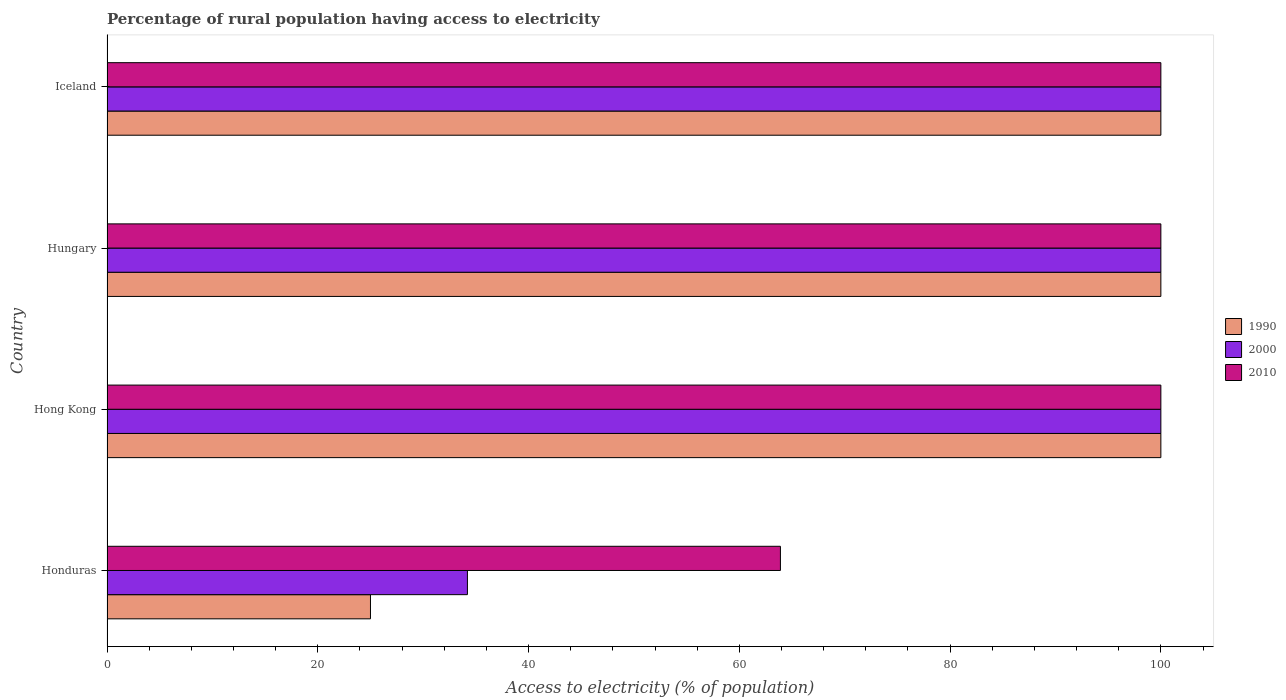How many different coloured bars are there?
Offer a terse response. 3. How many groups of bars are there?
Offer a very short reply. 4. Are the number of bars per tick equal to the number of legend labels?
Your answer should be very brief. Yes. Are the number of bars on each tick of the Y-axis equal?
Your answer should be compact. Yes. What is the label of the 3rd group of bars from the top?
Keep it short and to the point. Hong Kong. In how many cases, is the number of bars for a given country not equal to the number of legend labels?
Make the answer very short. 0. What is the percentage of rural population having access to electricity in 2000 in Hong Kong?
Make the answer very short. 100. Across all countries, what is the maximum percentage of rural population having access to electricity in 2000?
Offer a very short reply. 100. Across all countries, what is the minimum percentage of rural population having access to electricity in 2010?
Offer a very short reply. 63.9. In which country was the percentage of rural population having access to electricity in 2000 maximum?
Provide a succinct answer. Hong Kong. In which country was the percentage of rural population having access to electricity in 2000 minimum?
Ensure brevity in your answer.  Honduras. What is the total percentage of rural population having access to electricity in 1990 in the graph?
Offer a very short reply. 325. What is the difference between the percentage of rural population having access to electricity in 2000 in Hong Kong and that in Hungary?
Provide a short and direct response. 0. What is the difference between the percentage of rural population having access to electricity in 2000 in Honduras and the percentage of rural population having access to electricity in 2010 in Hong Kong?
Your response must be concise. -65.8. What is the average percentage of rural population having access to electricity in 2010 per country?
Provide a short and direct response. 90.97. What is the difference between the percentage of rural population having access to electricity in 2000 and percentage of rural population having access to electricity in 2010 in Hungary?
Provide a short and direct response. 0. In how many countries, is the percentage of rural population having access to electricity in 2010 greater than 64 %?
Your answer should be very brief. 3. What is the ratio of the percentage of rural population having access to electricity in 2000 in Hong Kong to that in Hungary?
Your answer should be compact. 1. Is the percentage of rural population having access to electricity in 2000 in Honduras less than that in Hong Kong?
Keep it short and to the point. Yes. What is the difference between the highest and the second highest percentage of rural population having access to electricity in 2000?
Offer a very short reply. 0. What is the difference between the highest and the lowest percentage of rural population having access to electricity in 2000?
Your response must be concise. 65.8. In how many countries, is the percentage of rural population having access to electricity in 1990 greater than the average percentage of rural population having access to electricity in 1990 taken over all countries?
Your answer should be compact. 3. Is the sum of the percentage of rural population having access to electricity in 1990 in Honduras and Iceland greater than the maximum percentage of rural population having access to electricity in 2010 across all countries?
Make the answer very short. Yes. What does the 2nd bar from the top in Iceland represents?
Your answer should be compact. 2000. Is it the case that in every country, the sum of the percentage of rural population having access to electricity in 2010 and percentage of rural population having access to electricity in 1990 is greater than the percentage of rural population having access to electricity in 2000?
Your answer should be compact. Yes. Does the graph contain any zero values?
Your answer should be very brief. No. Does the graph contain grids?
Provide a short and direct response. No. Where does the legend appear in the graph?
Give a very brief answer. Center right. How are the legend labels stacked?
Ensure brevity in your answer.  Vertical. What is the title of the graph?
Offer a terse response. Percentage of rural population having access to electricity. What is the label or title of the X-axis?
Your answer should be very brief. Access to electricity (% of population). What is the label or title of the Y-axis?
Your response must be concise. Country. What is the Access to electricity (% of population) in 1990 in Honduras?
Your answer should be compact. 25. What is the Access to electricity (% of population) in 2000 in Honduras?
Your answer should be very brief. 34.2. What is the Access to electricity (% of population) in 2010 in Honduras?
Give a very brief answer. 63.9. What is the Access to electricity (% of population) of 1990 in Hong Kong?
Provide a short and direct response. 100. Across all countries, what is the maximum Access to electricity (% of population) in 2010?
Your answer should be very brief. 100. Across all countries, what is the minimum Access to electricity (% of population) in 1990?
Provide a succinct answer. 25. Across all countries, what is the minimum Access to electricity (% of population) of 2000?
Give a very brief answer. 34.2. Across all countries, what is the minimum Access to electricity (% of population) of 2010?
Make the answer very short. 63.9. What is the total Access to electricity (% of population) in 1990 in the graph?
Make the answer very short. 325. What is the total Access to electricity (% of population) of 2000 in the graph?
Provide a succinct answer. 334.2. What is the total Access to electricity (% of population) of 2010 in the graph?
Make the answer very short. 363.9. What is the difference between the Access to electricity (% of population) in 1990 in Honduras and that in Hong Kong?
Give a very brief answer. -75. What is the difference between the Access to electricity (% of population) in 2000 in Honduras and that in Hong Kong?
Provide a succinct answer. -65.8. What is the difference between the Access to electricity (% of population) of 2010 in Honduras and that in Hong Kong?
Your answer should be compact. -36.1. What is the difference between the Access to electricity (% of population) of 1990 in Honduras and that in Hungary?
Keep it short and to the point. -75. What is the difference between the Access to electricity (% of population) in 2000 in Honduras and that in Hungary?
Ensure brevity in your answer.  -65.8. What is the difference between the Access to electricity (% of population) of 2010 in Honduras and that in Hungary?
Offer a terse response. -36.1. What is the difference between the Access to electricity (% of population) in 1990 in Honduras and that in Iceland?
Provide a short and direct response. -75. What is the difference between the Access to electricity (% of population) in 2000 in Honduras and that in Iceland?
Your response must be concise. -65.8. What is the difference between the Access to electricity (% of population) of 2010 in Honduras and that in Iceland?
Offer a very short reply. -36.1. What is the difference between the Access to electricity (% of population) of 1990 in Hong Kong and that in Hungary?
Provide a short and direct response. 0. What is the difference between the Access to electricity (% of population) of 2000 in Hong Kong and that in Hungary?
Your answer should be very brief. 0. What is the difference between the Access to electricity (% of population) of 2010 in Hong Kong and that in Hungary?
Your response must be concise. 0. What is the difference between the Access to electricity (% of population) in 2000 in Hong Kong and that in Iceland?
Ensure brevity in your answer.  0. What is the difference between the Access to electricity (% of population) of 1990 in Hungary and that in Iceland?
Offer a very short reply. 0. What is the difference between the Access to electricity (% of population) of 1990 in Honduras and the Access to electricity (% of population) of 2000 in Hong Kong?
Keep it short and to the point. -75. What is the difference between the Access to electricity (% of population) in 1990 in Honduras and the Access to electricity (% of population) in 2010 in Hong Kong?
Offer a terse response. -75. What is the difference between the Access to electricity (% of population) in 2000 in Honduras and the Access to electricity (% of population) in 2010 in Hong Kong?
Provide a succinct answer. -65.8. What is the difference between the Access to electricity (% of population) of 1990 in Honduras and the Access to electricity (% of population) of 2000 in Hungary?
Provide a succinct answer. -75. What is the difference between the Access to electricity (% of population) of 1990 in Honduras and the Access to electricity (% of population) of 2010 in Hungary?
Your answer should be very brief. -75. What is the difference between the Access to electricity (% of population) of 2000 in Honduras and the Access to electricity (% of population) of 2010 in Hungary?
Your answer should be very brief. -65.8. What is the difference between the Access to electricity (% of population) of 1990 in Honduras and the Access to electricity (% of population) of 2000 in Iceland?
Your answer should be compact. -75. What is the difference between the Access to electricity (% of population) in 1990 in Honduras and the Access to electricity (% of population) in 2010 in Iceland?
Keep it short and to the point. -75. What is the difference between the Access to electricity (% of population) of 2000 in Honduras and the Access to electricity (% of population) of 2010 in Iceland?
Offer a terse response. -65.8. What is the difference between the Access to electricity (% of population) of 1990 in Hong Kong and the Access to electricity (% of population) of 2000 in Iceland?
Give a very brief answer. 0. What is the difference between the Access to electricity (% of population) in 1990 in Hong Kong and the Access to electricity (% of population) in 2010 in Iceland?
Make the answer very short. 0. What is the difference between the Access to electricity (% of population) of 1990 in Hungary and the Access to electricity (% of population) of 2010 in Iceland?
Keep it short and to the point. 0. What is the difference between the Access to electricity (% of population) of 2000 in Hungary and the Access to electricity (% of population) of 2010 in Iceland?
Provide a succinct answer. 0. What is the average Access to electricity (% of population) in 1990 per country?
Your answer should be compact. 81.25. What is the average Access to electricity (% of population) of 2000 per country?
Keep it short and to the point. 83.55. What is the average Access to electricity (% of population) of 2010 per country?
Offer a terse response. 90.97. What is the difference between the Access to electricity (% of population) of 1990 and Access to electricity (% of population) of 2010 in Honduras?
Provide a succinct answer. -38.9. What is the difference between the Access to electricity (% of population) of 2000 and Access to electricity (% of population) of 2010 in Honduras?
Keep it short and to the point. -29.7. What is the difference between the Access to electricity (% of population) in 1990 and Access to electricity (% of population) in 2010 in Hong Kong?
Provide a succinct answer. 0. What is the difference between the Access to electricity (% of population) of 1990 and Access to electricity (% of population) of 2000 in Hungary?
Ensure brevity in your answer.  0. What is the difference between the Access to electricity (% of population) of 1990 and Access to electricity (% of population) of 2000 in Iceland?
Your answer should be very brief. 0. What is the difference between the Access to electricity (% of population) in 1990 and Access to electricity (% of population) in 2010 in Iceland?
Keep it short and to the point. 0. What is the ratio of the Access to electricity (% of population) of 2000 in Honduras to that in Hong Kong?
Make the answer very short. 0.34. What is the ratio of the Access to electricity (% of population) of 2010 in Honduras to that in Hong Kong?
Offer a terse response. 0.64. What is the ratio of the Access to electricity (% of population) of 1990 in Honduras to that in Hungary?
Provide a short and direct response. 0.25. What is the ratio of the Access to electricity (% of population) in 2000 in Honduras to that in Hungary?
Offer a very short reply. 0.34. What is the ratio of the Access to electricity (% of population) in 2010 in Honduras to that in Hungary?
Provide a short and direct response. 0.64. What is the ratio of the Access to electricity (% of population) in 2000 in Honduras to that in Iceland?
Give a very brief answer. 0.34. What is the ratio of the Access to electricity (% of population) in 2010 in Honduras to that in Iceland?
Your response must be concise. 0.64. What is the ratio of the Access to electricity (% of population) in 1990 in Hong Kong to that in Hungary?
Give a very brief answer. 1. What is the ratio of the Access to electricity (% of population) in 2000 in Hong Kong to that in Iceland?
Make the answer very short. 1. What is the ratio of the Access to electricity (% of population) of 2010 in Hong Kong to that in Iceland?
Ensure brevity in your answer.  1. What is the ratio of the Access to electricity (% of population) of 2000 in Hungary to that in Iceland?
Give a very brief answer. 1. What is the ratio of the Access to electricity (% of population) of 2010 in Hungary to that in Iceland?
Keep it short and to the point. 1. What is the difference between the highest and the lowest Access to electricity (% of population) of 1990?
Offer a very short reply. 75. What is the difference between the highest and the lowest Access to electricity (% of population) in 2000?
Keep it short and to the point. 65.8. What is the difference between the highest and the lowest Access to electricity (% of population) in 2010?
Ensure brevity in your answer.  36.1. 